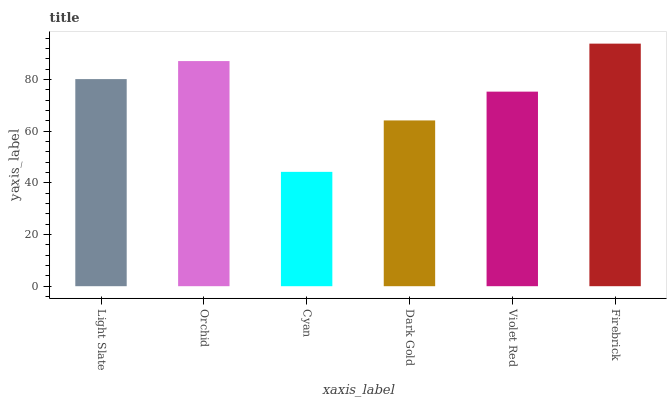Is Cyan the minimum?
Answer yes or no. Yes. Is Firebrick the maximum?
Answer yes or no. Yes. Is Orchid the minimum?
Answer yes or no. No. Is Orchid the maximum?
Answer yes or no. No. Is Orchid greater than Light Slate?
Answer yes or no. Yes. Is Light Slate less than Orchid?
Answer yes or no. Yes. Is Light Slate greater than Orchid?
Answer yes or no. No. Is Orchid less than Light Slate?
Answer yes or no. No. Is Light Slate the high median?
Answer yes or no. Yes. Is Violet Red the low median?
Answer yes or no. Yes. Is Dark Gold the high median?
Answer yes or no. No. Is Light Slate the low median?
Answer yes or no. No. 